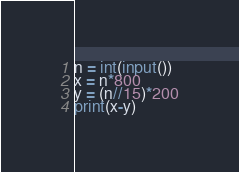Convert code to text. <code><loc_0><loc_0><loc_500><loc_500><_Python_>n = int(input())
x = n*800
y = (n//15)*200
print(x-y)</code> 